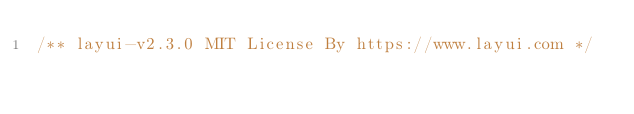Convert code to text. <code><loc_0><loc_0><loc_500><loc_500><_CSS_>/** layui-v2.3.0 MIT License By https://www.layui.com */</code> 